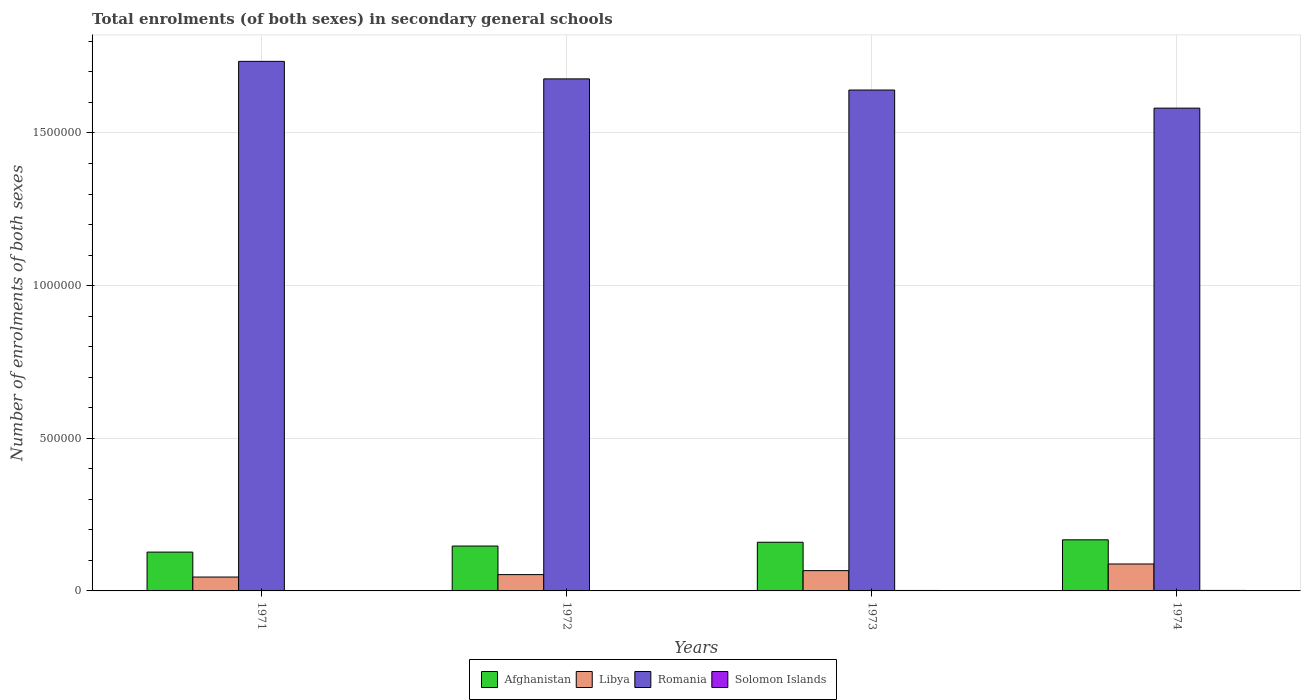How many groups of bars are there?
Give a very brief answer. 4. Are the number of bars per tick equal to the number of legend labels?
Provide a short and direct response. Yes. Are the number of bars on each tick of the X-axis equal?
Make the answer very short. Yes. How many bars are there on the 1st tick from the left?
Provide a short and direct response. 4. What is the label of the 3rd group of bars from the left?
Provide a short and direct response. 1973. In how many cases, is the number of bars for a given year not equal to the number of legend labels?
Ensure brevity in your answer.  0. What is the number of enrolments in secondary schools in Solomon Islands in 1974?
Provide a short and direct response. 1625. Across all years, what is the maximum number of enrolments in secondary schools in Libya?
Keep it short and to the point. 8.82e+04. Across all years, what is the minimum number of enrolments in secondary schools in Afghanistan?
Your response must be concise. 1.27e+05. What is the total number of enrolments in secondary schools in Libya in the graph?
Your answer should be compact. 2.54e+05. What is the difference between the number of enrolments in secondary schools in Afghanistan in 1971 and that in 1974?
Give a very brief answer. -4.02e+04. What is the difference between the number of enrolments in secondary schools in Romania in 1973 and the number of enrolments in secondary schools in Solomon Islands in 1971?
Offer a terse response. 1.64e+06. What is the average number of enrolments in secondary schools in Afghanistan per year?
Give a very brief answer. 1.50e+05. In the year 1972, what is the difference between the number of enrolments in secondary schools in Libya and number of enrolments in secondary schools in Romania?
Your answer should be very brief. -1.62e+06. In how many years, is the number of enrolments in secondary schools in Afghanistan greater than 1200000?
Your answer should be very brief. 0. What is the ratio of the number of enrolments in secondary schools in Romania in 1972 to that in 1973?
Your answer should be compact. 1.02. Is the number of enrolments in secondary schools in Romania in 1972 less than that in 1974?
Offer a terse response. No. Is the difference between the number of enrolments in secondary schools in Libya in 1972 and 1974 greater than the difference between the number of enrolments in secondary schools in Romania in 1972 and 1974?
Ensure brevity in your answer.  No. What is the difference between the highest and the second highest number of enrolments in secondary schools in Solomon Islands?
Ensure brevity in your answer.  99. What is the difference between the highest and the lowest number of enrolments in secondary schools in Solomon Islands?
Make the answer very short. 470. Is the sum of the number of enrolments in secondary schools in Solomon Islands in 1972 and 1973 greater than the maximum number of enrolments in secondary schools in Afghanistan across all years?
Offer a terse response. No. Is it the case that in every year, the sum of the number of enrolments in secondary schools in Romania and number of enrolments in secondary schools in Solomon Islands is greater than the sum of number of enrolments in secondary schools in Afghanistan and number of enrolments in secondary schools in Libya?
Your answer should be compact. No. What does the 4th bar from the left in 1971 represents?
Provide a succinct answer. Solomon Islands. What does the 4th bar from the right in 1973 represents?
Give a very brief answer. Afghanistan. Is it the case that in every year, the sum of the number of enrolments in secondary schools in Afghanistan and number of enrolments in secondary schools in Solomon Islands is greater than the number of enrolments in secondary schools in Libya?
Offer a terse response. Yes. How many bars are there?
Your answer should be very brief. 16. Are all the bars in the graph horizontal?
Your answer should be very brief. No. What is the difference between two consecutive major ticks on the Y-axis?
Your answer should be very brief. 5.00e+05. Are the values on the major ticks of Y-axis written in scientific E-notation?
Offer a very short reply. No. Does the graph contain any zero values?
Offer a terse response. No. Does the graph contain grids?
Your answer should be very brief. Yes. What is the title of the graph?
Offer a very short reply. Total enrolments (of both sexes) in secondary general schools. Does "Middle income" appear as one of the legend labels in the graph?
Give a very brief answer. No. What is the label or title of the X-axis?
Make the answer very short. Years. What is the label or title of the Y-axis?
Keep it short and to the point. Number of enrolments of both sexes. What is the Number of enrolments of both sexes of Afghanistan in 1971?
Provide a short and direct response. 1.27e+05. What is the Number of enrolments of both sexes of Libya in 1971?
Make the answer very short. 4.55e+04. What is the Number of enrolments of both sexes in Romania in 1971?
Your answer should be very brief. 1.73e+06. What is the Number of enrolments of both sexes in Solomon Islands in 1971?
Your answer should be very brief. 1155. What is the Number of enrolments of both sexes of Afghanistan in 1972?
Ensure brevity in your answer.  1.47e+05. What is the Number of enrolments of both sexes of Libya in 1972?
Offer a terse response. 5.34e+04. What is the Number of enrolments of both sexes of Romania in 1972?
Keep it short and to the point. 1.68e+06. What is the Number of enrolments of both sexes in Solomon Islands in 1972?
Provide a short and direct response. 1303. What is the Number of enrolments of both sexes of Afghanistan in 1973?
Your answer should be compact. 1.59e+05. What is the Number of enrolments of both sexes of Libya in 1973?
Provide a short and direct response. 6.64e+04. What is the Number of enrolments of both sexes in Romania in 1973?
Ensure brevity in your answer.  1.64e+06. What is the Number of enrolments of both sexes of Solomon Islands in 1973?
Provide a short and direct response. 1526. What is the Number of enrolments of both sexes in Afghanistan in 1974?
Provide a succinct answer. 1.67e+05. What is the Number of enrolments of both sexes in Libya in 1974?
Provide a succinct answer. 8.82e+04. What is the Number of enrolments of both sexes of Romania in 1974?
Offer a very short reply. 1.58e+06. What is the Number of enrolments of both sexes of Solomon Islands in 1974?
Keep it short and to the point. 1625. Across all years, what is the maximum Number of enrolments of both sexes in Afghanistan?
Keep it short and to the point. 1.67e+05. Across all years, what is the maximum Number of enrolments of both sexes of Libya?
Your answer should be compact. 8.82e+04. Across all years, what is the maximum Number of enrolments of both sexes in Romania?
Provide a short and direct response. 1.73e+06. Across all years, what is the maximum Number of enrolments of both sexes in Solomon Islands?
Provide a succinct answer. 1625. Across all years, what is the minimum Number of enrolments of both sexes in Afghanistan?
Provide a succinct answer. 1.27e+05. Across all years, what is the minimum Number of enrolments of both sexes of Libya?
Your response must be concise. 4.55e+04. Across all years, what is the minimum Number of enrolments of both sexes of Romania?
Your answer should be very brief. 1.58e+06. Across all years, what is the minimum Number of enrolments of both sexes in Solomon Islands?
Offer a terse response. 1155. What is the total Number of enrolments of both sexes in Afghanistan in the graph?
Offer a very short reply. 6.01e+05. What is the total Number of enrolments of both sexes of Libya in the graph?
Give a very brief answer. 2.54e+05. What is the total Number of enrolments of both sexes of Romania in the graph?
Keep it short and to the point. 6.63e+06. What is the total Number of enrolments of both sexes of Solomon Islands in the graph?
Keep it short and to the point. 5609. What is the difference between the Number of enrolments of both sexes of Afghanistan in 1971 and that in 1972?
Ensure brevity in your answer.  -1.98e+04. What is the difference between the Number of enrolments of both sexes of Libya in 1971 and that in 1972?
Ensure brevity in your answer.  -7944. What is the difference between the Number of enrolments of both sexes of Romania in 1971 and that in 1972?
Give a very brief answer. 5.74e+04. What is the difference between the Number of enrolments of both sexes of Solomon Islands in 1971 and that in 1972?
Offer a very short reply. -148. What is the difference between the Number of enrolments of both sexes of Afghanistan in 1971 and that in 1973?
Your answer should be very brief. -3.23e+04. What is the difference between the Number of enrolments of both sexes of Libya in 1971 and that in 1973?
Give a very brief answer. -2.09e+04. What is the difference between the Number of enrolments of both sexes of Romania in 1971 and that in 1973?
Your response must be concise. 9.40e+04. What is the difference between the Number of enrolments of both sexes of Solomon Islands in 1971 and that in 1973?
Your answer should be very brief. -371. What is the difference between the Number of enrolments of both sexes of Afghanistan in 1971 and that in 1974?
Offer a very short reply. -4.02e+04. What is the difference between the Number of enrolments of both sexes of Libya in 1971 and that in 1974?
Your answer should be compact. -4.27e+04. What is the difference between the Number of enrolments of both sexes in Romania in 1971 and that in 1974?
Give a very brief answer. 1.53e+05. What is the difference between the Number of enrolments of both sexes of Solomon Islands in 1971 and that in 1974?
Give a very brief answer. -470. What is the difference between the Number of enrolments of both sexes in Afghanistan in 1972 and that in 1973?
Offer a very short reply. -1.25e+04. What is the difference between the Number of enrolments of both sexes in Libya in 1972 and that in 1973?
Offer a terse response. -1.30e+04. What is the difference between the Number of enrolments of both sexes in Romania in 1972 and that in 1973?
Keep it short and to the point. 3.66e+04. What is the difference between the Number of enrolments of both sexes of Solomon Islands in 1972 and that in 1973?
Make the answer very short. -223. What is the difference between the Number of enrolments of both sexes in Afghanistan in 1972 and that in 1974?
Your answer should be very brief. -2.04e+04. What is the difference between the Number of enrolments of both sexes in Libya in 1972 and that in 1974?
Ensure brevity in your answer.  -3.48e+04. What is the difference between the Number of enrolments of both sexes of Romania in 1972 and that in 1974?
Provide a succinct answer. 9.58e+04. What is the difference between the Number of enrolments of both sexes in Solomon Islands in 1972 and that in 1974?
Ensure brevity in your answer.  -322. What is the difference between the Number of enrolments of both sexes of Afghanistan in 1973 and that in 1974?
Offer a terse response. -7933. What is the difference between the Number of enrolments of both sexes of Libya in 1973 and that in 1974?
Provide a succinct answer. -2.18e+04. What is the difference between the Number of enrolments of both sexes of Romania in 1973 and that in 1974?
Keep it short and to the point. 5.92e+04. What is the difference between the Number of enrolments of both sexes in Solomon Islands in 1973 and that in 1974?
Give a very brief answer. -99. What is the difference between the Number of enrolments of both sexes of Afghanistan in 1971 and the Number of enrolments of both sexes of Libya in 1972?
Make the answer very short. 7.37e+04. What is the difference between the Number of enrolments of both sexes of Afghanistan in 1971 and the Number of enrolments of both sexes of Romania in 1972?
Give a very brief answer. -1.55e+06. What is the difference between the Number of enrolments of both sexes in Afghanistan in 1971 and the Number of enrolments of both sexes in Solomon Islands in 1972?
Offer a very short reply. 1.26e+05. What is the difference between the Number of enrolments of both sexes in Libya in 1971 and the Number of enrolments of both sexes in Romania in 1972?
Offer a very short reply. -1.63e+06. What is the difference between the Number of enrolments of both sexes in Libya in 1971 and the Number of enrolments of both sexes in Solomon Islands in 1972?
Provide a short and direct response. 4.42e+04. What is the difference between the Number of enrolments of both sexes of Romania in 1971 and the Number of enrolments of both sexes of Solomon Islands in 1972?
Your answer should be compact. 1.73e+06. What is the difference between the Number of enrolments of both sexes of Afghanistan in 1971 and the Number of enrolments of both sexes of Libya in 1973?
Offer a terse response. 6.07e+04. What is the difference between the Number of enrolments of both sexes of Afghanistan in 1971 and the Number of enrolments of both sexes of Romania in 1973?
Your response must be concise. -1.51e+06. What is the difference between the Number of enrolments of both sexes of Afghanistan in 1971 and the Number of enrolments of both sexes of Solomon Islands in 1973?
Make the answer very short. 1.26e+05. What is the difference between the Number of enrolments of both sexes in Libya in 1971 and the Number of enrolments of both sexes in Romania in 1973?
Provide a short and direct response. -1.60e+06. What is the difference between the Number of enrolments of both sexes of Libya in 1971 and the Number of enrolments of both sexes of Solomon Islands in 1973?
Keep it short and to the point. 4.40e+04. What is the difference between the Number of enrolments of both sexes in Romania in 1971 and the Number of enrolments of both sexes in Solomon Islands in 1973?
Offer a terse response. 1.73e+06. What is the difference between the Number of enrolments of both sexes in Afghanistan in 1971 and the Number of enrolments of both sexes in Libya in 1974?
Your response must be concise. 3.89e+04. What is the difference between the Number of enrolments of both sexes of Afghanistan in 1971 and the Number of enrolments of both sexes of Romania in 1974?
Provide a short and direct response. -1.45e+06. What is the difference between the Number of enrolments of both sexes in Afghanistan in 1971 and the Number of enrolments of both sexes in Solomon Islands in 1974?
Ensure brevity in your answer.  1.26e+05. What is the difference between the Number of enrolments of both sexes in Libya in 1971 and the Number of enrolments of both sexes in Romania in 1974?
Keep it short and to the point. -1.54e+06. What is the difference between the Number of enrolments of both sexes of Libya in 1971 and the Number of enrolments of both sexes of Solomon Islands in 1974?
Make the answer very short. 4.39e+04. What is the difference between the Number of enrolments of both sexes in Romania in 1971 and the Number of enrolments of both sexes in Solomon Islands in 1974?
Your answer should be compact. 1.73e+06. What is the difference between the Number of enrolments of both sexes of Afghanistan in 1972 and the Number of enrolments of both sexes of Libya in 1973?
Offer a terse response. 8.06e+04. What is the difference between the Number of enrolments of both sexes of Afghanistan in 1972 and the Number of enrolments of both sexes of Romania in 1973?
Ensure brevity in your answer.  -1.49e+06. What is the difference between the Number of enrolments of both sexes of Afghanistan in 1972 and the Number of enrolments of both sexes of Solomon Islands in 1973?
Provide a short and direct response. 1.45e+05. What is the difference between the Number of enrolments of both sexes in Libya in 1972 and the Number of enrolments of both sexes in Romania in 1973?
Make the answer very short. -1.59e+06. What is the difference between the Number of enrolments of both sexes in Libya in 1972 and the Number of enrolments of both sexes in Solomon Islands in 1973?
Keep it short and to the point. 5.19e+04. What is the difference between the Number of enrolments of both sexes in Romania in 1972 and the Number of enrolments of both sexes in Solomon Islands in 1973?
Give a very brief answer. 1.68e+06. What is the difference between the Number of enrolments of both sexes of Afghanistan in 1972 and the Number of enrolments of both sexes of Libya in 1974?
Offer a terse response. 5.88e+04. What is the difference between the Number of enrolments of both sexes of Afghanistan in 1972 and the Number of enrolments of both sexes of Romania in 1974?
Provide a short and direct response. -1.43e+06. What is the difference between the Number of enrolments of both sexes in Afghanistan in 1972 and the Number of enrolments of both sexes in Solomon Islands in 1974?
Offer a terse response. 1.45e+05. What is the difference between the Number of enrolments of both sexes of Libya in 1972 and the Number of enrolments of both sexes of Romania in 1974?
Your response must be concise. -1.53e+06. What is the difference between the Number of enrolments of both sexes in Libya in 1972 and the Number of enrolments of both sexes in Solomon Islands in 1974?
Give a very brief answer. 5.18e+04. What is the difference between the Number of enrolments of both sexes in Romania in 1972 and the Number of enrolments of both sexes in Solomon Islands in 1974?
Ensure brevity in your answer.  1.68e+06. What is the difference between the Number of enrolments of both sexes of Afghanistan in 1973 and the Number of enrolments of both sexes of Libya in 1974?
Your response must be concise. 7.12e+04. What is the difference between the Number of enrolments of both sexes in Afghanistan in 1973 and the Number of enrolments of both sexes in Romania in 1974?
Make the answer very short. -1.42e+06. What is the difference between the Number of enrolments of both sexes of Afghanistan in 1973 and the Number of enrolments of both sexes of Solomon Islands in 1974?
Your answer should be very brief. 1.58e+05. What is the difference between the Number of enrolments of both sexes of Libya in 1973 and the Number of enrolments of both sexes of Romania in 1974?
Offer a very short reply. -1.51e+06. What is the difference between the Number of enrolments of both sexes in Libya in 1973 and the Number of enrolments of both sexes in Solomon Islands in 1974?
Offer a very short reply. 6.48e+04. What is the difference between the Number of enrolments of both sexes of Romania in 1973 and the Number of enrolments of both sexes of Solomon Islands in 1974?
Your response must be concise. 1.64e+06. What is the average Number of enrolments of both sexes in Afghanistan per year?
Your response must be concise. 1.50e+05. What is the average Number of enrolments of both sexes in Libya per year?
Your answer should be compact. 6.34e+04. What is the average Number of enrolments of both sexes in Romania per year?
Ensure brevity in your answer.  1.66e+06. What is the average Number of enrolments of both sexes of Solomon Islands per year?
Your response must be concise. 1402.25. In the year 1971, what is the difference between the Number of enrolments of both sexes of Afghanistan and Number of enrolments of both sexes of Libya?
Make the answer very short. 8.17e+04. In the year 1971, what is the difference between the Number of enrolments of both sexes of Afghanistan and Number of enrolments of both sexes of Romania?
Provide a short and direct response. -1.61e+06. In the year 1971, what is the difference between the Number of enrolments of both sexes in Afghanistan and Number of enrolments of both sexes in Solomon Islands?
Your answer should be compact. 1.26e+05. In the year 1971, what is the difference between the Number of enrolments of both sexes in Libya and Number of enrolments of both sexes in Romania?
Provide a short and direct response. -1.69e+06. In the year 1971, what is the difference between the Number of enrolments of both sexes in Libya and Number of enrolments of both sexes in Solomon Islands?
Provide a short and direct response. 4.43e+04. In the year 1971, what is the difference between the Number of enrolments of both sexes of Romania and Number of enrolments of both sexes of Solomon Islands?
Make the answer very short. 1.73e+06. In the year 1972, what is the difference between the Number of enrolments of both sexes in Afghanistan and Number of enrolments of both sexes in Libya?
Offer a terse response. 9.36e+04. In the year 1972, what is the difference between the Number of enrolments of both sexes in Afghanistan and Number of enrolments of both sexes in Romania?
Provide a succinct answer. -1.53e+06. In the year 1972, what is the difference between the Number of enrolments of both sexes of Afghanistan and Number of enrolments of both sexes of Solomon Islands?
Your answer should be compact. 1.46e+05. In the year 1972, what is the difference between the Number of enrolments of both sexes in Libya and Number of enrolments of both sexes in Romania?
Your answer should be very brief. -1.62e+06. In the year 1972, what is the difference between the Number of enrolments of both sexes in Libya and Number of enrolments of both sexes in Solomon Islands?
Keep it short and to the point. 5.21e+04. In the year 1972, what is the difference between the Number of enrolments of both sexes in Romania and Number of enrolments of both sexes in Solomon Islands?
Give a very brief answer. 1.68e+06. In the year 1973, what is the difference between the Number of enrolments of both sexes in Afghanistan and Number of enrolments of both sexes in Libya?
Keep it short and to the point. 9.30e+04. In the year 1973, what is the difference between the Number of enrolments of both sexes in Afghanistan and Number of enrolments of both sexes in Romania?
Your answer should be compact. -1.48e+06. In the year 1973, what is the difference between the Number of enrolments of both sexes of Afghanistan and Number of enrolments of both sexes of Solomon Islands?
Provide a short and direct response. 1.58e+05. In the year 1973, what is the difference between the Number of enrolments of both sexes of Libya and Number of enrolments of both sexes of Romania?
Your response must be concise. -1.57e+06. In the year 1973, what is the difference between the Number of enrolments of both sexes of Libya and Number of enrolments of both sexes of Solomon Islands?
Offer a terse response. 6.49e+04. In the year 1973, what is the difference between the Number of enrolments of both sexes of Romania and Number of enrolments of both sexes of Solomon Islands?
Provide a short and direct response. 1.64e+06. In the year 1974, what is the difference between the Number of enrolments of both sexes in Afghanistan and Number of enrolments of both sexes in Libya?
Give a very brief answer. 7.92e+04. In the year 1974, what is the difference between the Number of enrolments of both sexes in Afghanistan and Number of enrolments of both sexes in Romania?
Your response must be concise. -1.41e+06. In the year 1974, what is the difference between the Number of enrolments of both sexes in Afghanistan and Number of enrolments of both sexes in Solomon Islands?
Your answer should be very brief. 1.66e+05. In the year 1974, what is the difference between the Number of enrolments of both sexes in Libya and Number of enrolments of both sexes in Romania?
Your answer should be compact. -1.49e+06. In the year 1974, what is the difference between the Number of enrolments of both sexes in Libya and Number of enrolments of both sexes in Solomon Islands?
Make the answer very short. 8.66e+04. In the year 1974, what is the difference between the Number of enrolments of both sexes of Romania and Number of enrolments of both sexes of Solomon Islands?
Keep it short and to the point. 1.58e+06. What is the ratio of the Number of enrolments of both sexes of Afghanistan in 1971 to that in 1972?
Provide a short and direct response. 0.87. What is the ratio of the Number of enrolments of both sexes of Libya in 1971 to that in 1972?
Provide a short and direct response. 0.85. What is the ratio of the Number of enrolments of both sexes of Romania in 1971 to that in 1972?
Give a very brief answer. 1.03. What is the ratio of the Number of enrolments of both sexes of Solomon Islands in 1971 to that in 1972?
Your answer should be compact. 0.89. What is the ratio of the Number of enrolments of both sexes of Afghanistan in 1971 to that in 1973?
Your answer should be compact. 0.8. What is the ratio of the Number of enrolments of both sexes of Libya in 1971 to that in 1973?
Offer a very short reply. 0.68. What is the ratio of the Number of enrolments of both sexes of Romania in 1971 to that in 1973?
Make the answer very short. 1.06. What is the ratio of the Number of enrolments of both sexes of Solomon Islands in 1971 to that in 1973?
Make the answer very short. 0.76. What is the ratio of the Number of enrolments of both sexes in Afghanistan in 1971 to that in 1974?
Keep it short and to the point. 0.76. What is the ratio of the Number of enrolments of both sexes in Libya in 1971 to that in 1974?
Provide a succinct answer. 0.52. What is the ratio of the Number of enrolments of both sexes of Romania in 1971 to that in 1974?
Your response must be concise. 1.1. What is the ratio of the Number of enrolments of both sexes in Solomon Islands in 1971 to that in 1974?
Your response must be concise. 0.71. What is the ratio of the Number of enrolments of both sexes of Afghanistan in 1972 to that in 1973?
Ensure brevity in your answer.  0.92. What is the ratio of the Number of enrolments of both sexes of Libya in 1972 to that in 1973?
Give a very brief answer. 0.8. What is the ratio of the Number of enrolments of both sexes in Romania in 1972 to that in 1973?
Your answer should be compact. 1.02. What is the ratio of the Number of enrolments of both sexes of Solomon Islands in 1972 to that in 1973?
Ensure brevity in your answer.  0.85. What is the ratio of the Number of enrolments of both sexes in Afghanistan in 1972 to that in 1974?
Make the answer very short. 0.88. What is the ratio of the Number of enrolments of both sexes in Libya in 1972 to that in 1974?
Provide a succinct answer. 0.61. What is the ratio of the Number of enrolments of both sexes of Romania in 1972 to that in 1974?
Provide a succinct answer. 1.06. What is the ratio of the Number of enrolments of both sexes in Solomon Islands in 1972 to that in 1974?
Provide a short and direct response. 0.8. What is the ratio of the Number of enrolments of both sexes of Afghanistan in 1973 to that in 1974?
Your answer should be very brief. 0.95. What is the ratio of the Number of enrolments of both sexes in Libya in 1973 to that in 1974?
Your answer should be compact. 0.75. What is the ratio of the Number of enrolments of both sexes in Romania in 1973 to that in 1974?
Offer a very short reply. 1.04. What is the ratio of the Number of enrolments of both sexes of Solomon Islands in 1973 to that in 1974?
Offer a very short reply. 0.94. What is the difference between the highest and the second highest Number of enrolments of both sexes in Afghanistan?
Your answer should be compact. 7933. What is the difference between the highest and the second highest Number of enrolments of both sexes in Libya?
Offer a terse response. 2.18e+04. What is the difference between the highest and the second highest Number of enrolments of both sexes in Romania?
Offer a terse response. 5.74e+04. What is the difference between the highest and the second highest Number of enrolments of both sexes in Solomon Islands?
Your answer should be very brief. 99. What is the difference between the highest and the lowest Number of enrolments of both sexes in Afghanistan?
Provide a succinct answer. 4.02e+04. What is the difference between the highest and the lowest Number of enrolments of both sexes of Libya?
Offer a very short reply. 4.27e+04. What is the difference between the highest and the lowest Number of enrolments of both sexes in Romania?
Offer a terse response. 1.53e+05. What is the difference between the highest and the lowest Number of enrolments of both sexes of Solomon Islands?
Make the answer very short. 470. 